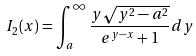<formula> <loc_0><loc_0><loc_500><loc_500>I _ { 2 } ( x ) = \int _ { a } ^ { \infty } \frac { y \sqrt { y ^ { 2 } - a ^ { 2 } } } { e ^ { y - x } + 1 } d y</formula> 